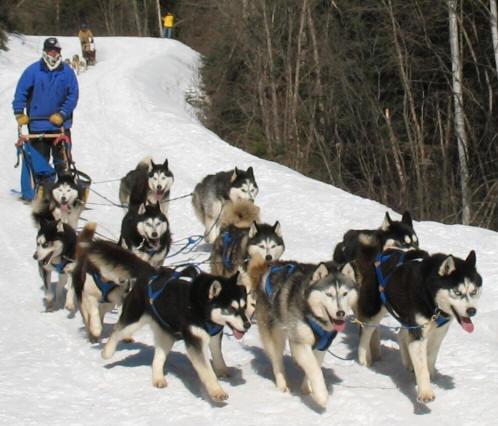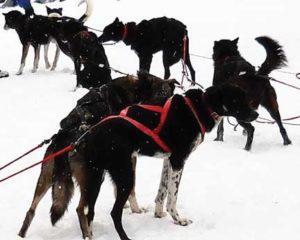The first image is the image on the left, the second image is the image on the right. For the images shown, is this caption "In one image, a team of dogs is pulling a sled on which a person is standing, while a second image shows a team of dogs up close, standing in their harnesses." true? Answer yes or no. Yes. 